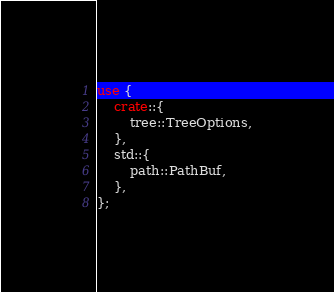Convert code to text. <code><loc_0><loc_0><loc_500><loc_500><_Rust_>use {
    crate::{
        tree::TreeOptions,
    },
    std::{
        path::PathBuf,
    },
};

</code> 